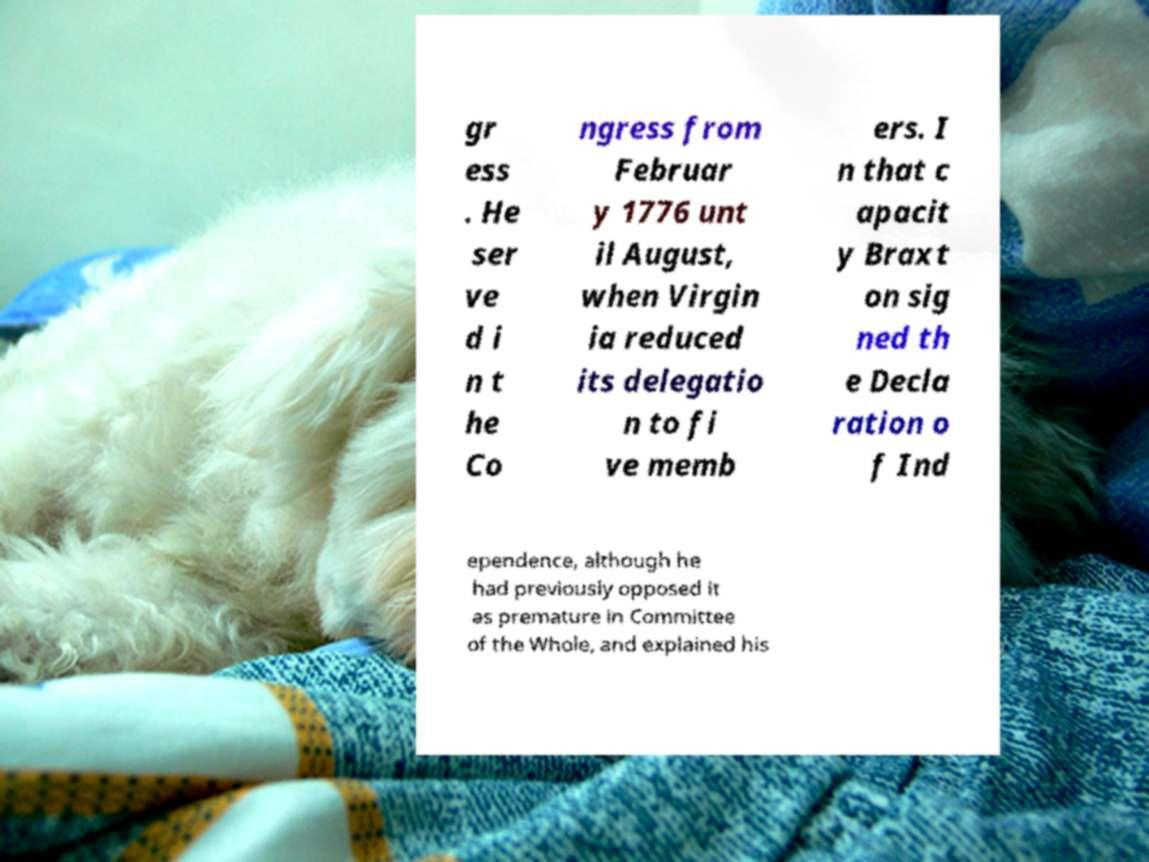Could you assist in decoding the text presented in this image and type it out clearly? gr ess . He ser ve d i n t he Co ngress from Februar y 1776 unt il August, when Virgin ia reduced its delegatio n to fi ve memb ers. I n that c apacit y Braxt on sig ned th e Decla ration o f Ind ependence, although he had previously opposed it as premature in Committee of the Whole, and explained his 